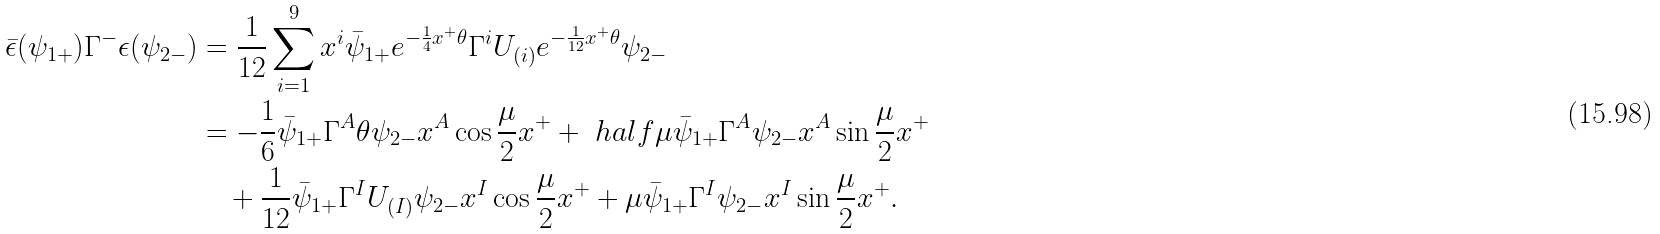<formula> <loc_0><loc_0><loc_500><loc_500>\bar { \epsilon } ( \psi _ { 1 + } ) \Gamma ^ { - } \epsilon ( \psi _ { 2 - } ) & = \frac { 1 } { 1 2 } \sum _ { i = 1 } ^ { 9 } x ^ { i } \bar { \psi } _ { 1 + } e ^ { - \frac { 1 } { 4 } x ^ { + } \theta } \Gamma ^ { i } U _ { ( i ) } e ^ { - \frac { 1 } { 1 2 } x ^ { + } \theta } \psi _ { 2 - } \\ & = - \frac { 1 } { 6 } \bar { \psi } _ { 1 + } \Gamma ^ { A } \theta \psi _ { 2 - } x ^ { A } \cos \frac { \mu } { 2 } x ^ { + } + \ h a l f \mu \bar { \psi } _ { 1 + } \Gamma ^ { A } \psi _ { 2 - } x ^ { A } \sin \frac { \mu } { 2 } x ^ { + } \\ & \quad + \frac { 1 } { 1 2 } \bar { \psi } _ { 1 + } \Gamma ^ { I } U _ { ( I ) } \psi _ { 2 - } x ^ { I } \cos \frac { \mu } { 2 } x ^ { + } + \mu \bar { \psi } _ { 1 + } \Gamma ^ { I } \psi _ { 2 - } x ^ { I } \sin \frac { \mu } { 2 } x ^ { + } .</formula> 